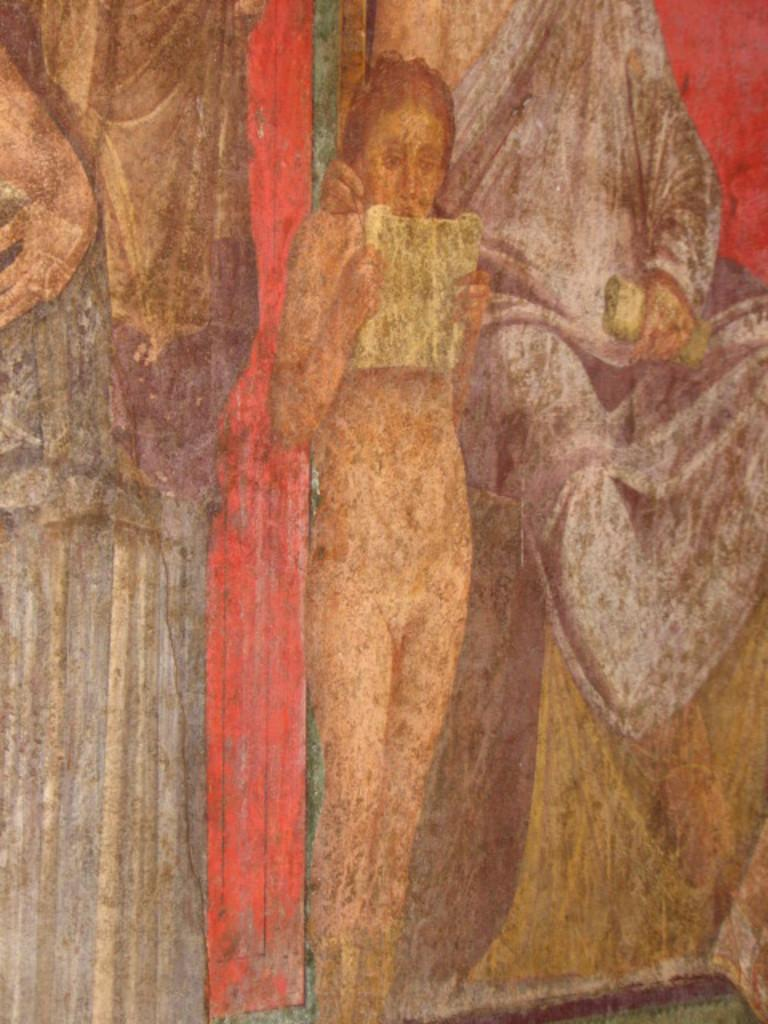What is the main subject of the painting in the image? The painting depicts a woman. Are there any other subjects in the painting besides the woman? Yes, the painting also depicts people. What type of sugar is being used to paint the woman in the image? There is no sugar present in the image, as the painting is not created with sugar. Can you see any mittens in the painting? There are no mittens depicted in the painting; it only features a woman and other people. 